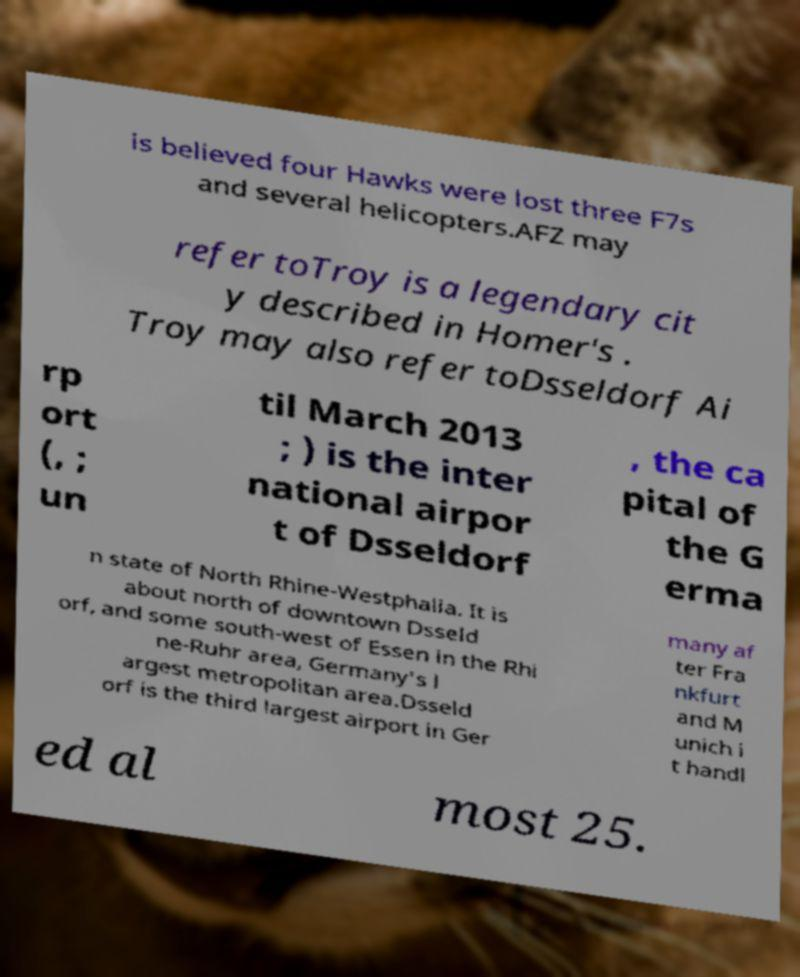Can you read and provide the text displayed in the image?This photo seems to have some interesting text. Can you extract and type it out for me? is believed four Hawks were lost three F7s and several helicopters.AFZ may refer toTroy is a legendary cit y described in Homer's . Troy may also refer toDsseldorf Ai rp ort (, ; un til March 2013 ; ) is the inter national airpor t of Dsseldorf , the ca pital of the G erma n state of North Rhine-Westphalia. It is about north of downtown Dsseld orf, and some south-west of Essen in the Rhi ne-Ruhr area, Germany's l argest metropolitan area.Dsseld orf is the third largest airport in Ger many af ter Fra nkfurt and M unich i t handl ed al most 25. 